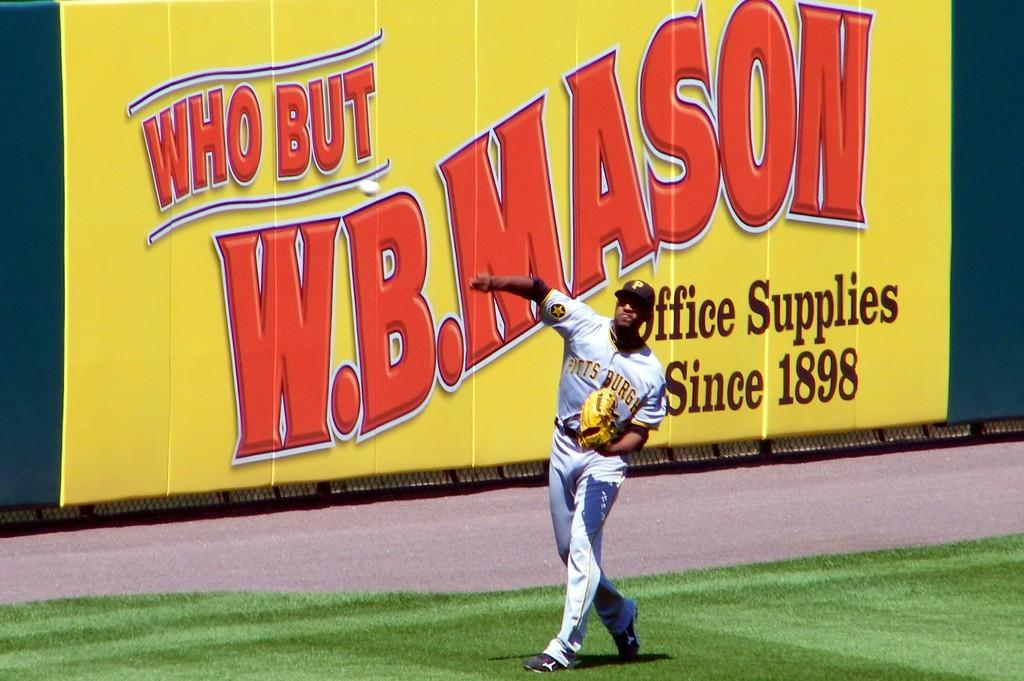Provide a one-sentence caption for the provided image. W.B. Mason sign is behind a baseball player on the field. 